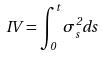Convert formula to latex. <formula><loc_0><loc_0><loc_500><loc_500>I V = \int _ { 0 } ^ { t } \sigma _ { s } ^ { 2 } d s</formula> 